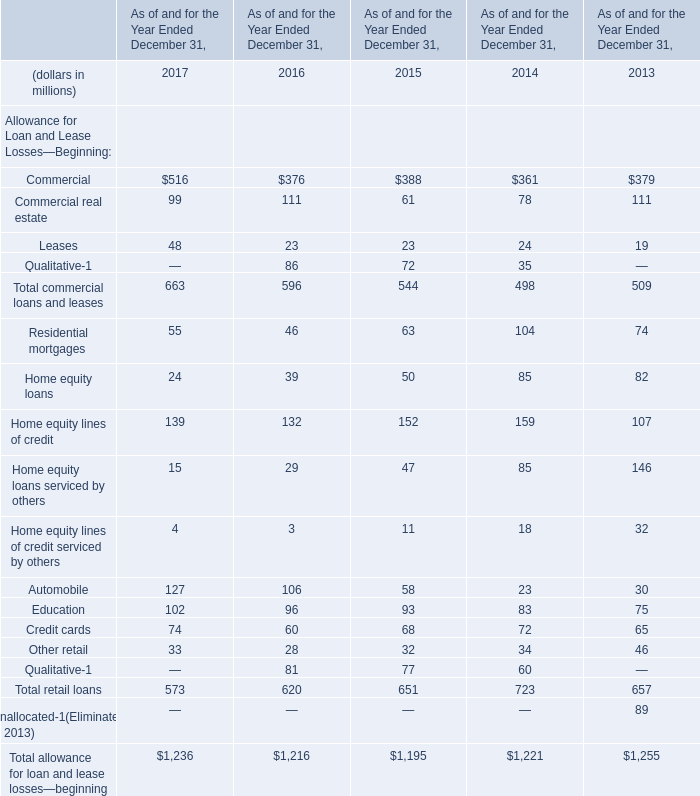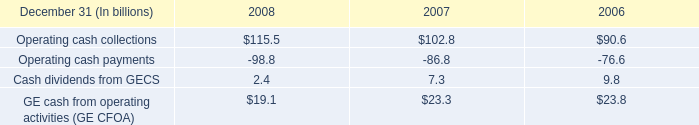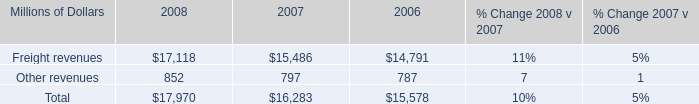What is the growing rate of Other retail in the year with the most Total retail loans? (in million) 
Computations: ((34 - 46) / 46)
Answer: -0.26087. 